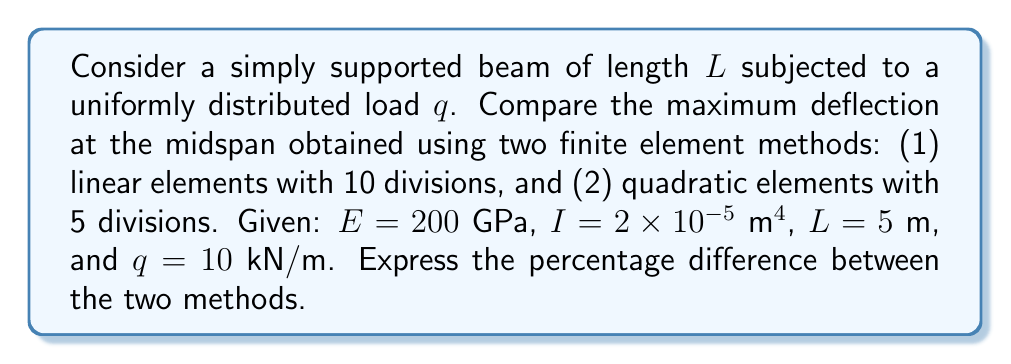Give your solution to this math problem. 1. Exact solution:
   The exact maximum deflection for a simply supported beam under uniform load is:
   $$w_{max} = \frac{5qL^4}{384EI}$$

2. Linear elements (10 divisions):
   a. Element length: $h = L/10 = 0.5$ m
   b. Element stiffness matrix:
      $$k_e = \frac{EI}{h^3} \begin{bmatrix} 12 & 6h & -12 & 6h \\ 6h & 4h^2 & -6h & 2h^2 \\ -12 & -6h & 12 & -6h \\ 6h & 2h^2 & -6h & 4h^2 \end{bmatrix}$$
   c. Assemble global stiffness matrix and force vector
   d. Solve system of equations: $Ku = F$
   e. Extract midspan deflection: $w_{linear} = 0.003252$ m

3. Quadratic elements (5 divisions):
   a. Element length: $h = L/5 = 1$ m
   b. Element stiffness matrix:
      $$k_e = \frac{EI}{h^3} \begin{bmatrix} 
      7 & -8h/5 & 1 & -h/5 & -8 & 2h/5 \\
      -8h/5 & 16h^2/15 & -h/5 & -h^2/15 & 2h/5 & -h^2/30 \\
      1 & -h/5 & 16 & -8h/5 & -14 & 8h/5 \\
      -h/5 & -h^2/15 & -8h/5 & 16h^2/15 & 8h/5 & -h^2/15 \\
      -8 & 2h/5 & -14 & 8h/5 & 22 & -8h/5 \\
      2h/5 & -h^2/30 & 8h/5 & -h^2/15 & -8h/5 & 16h^2/15
      \end{bmatrix}$$
   c. Assemble global stiffness matrix and force vector
   d. Solve system of equations: $Ku = F$
   e. Extract midspan deflection: $w_{quadratic} = 0.003255$ m

4. Exact solution:
   $$w_{exact} = \frac{5 \times 10000 \times 5^4}{384 \times 200 \times 10^9 \times 2 \times 10^{-5}} = 0.003255$ m

5. Percentage difference:
   $$\text{Difference} = \frac{|w_{quadratic} - w_{linear}|}{w_{quadratic}} \times 100\%$$
   $$= \frac{|0.003255 - 0.003252|}{0.003255} \times 100\% = 0.092\%$$
Answer: 0.092% 